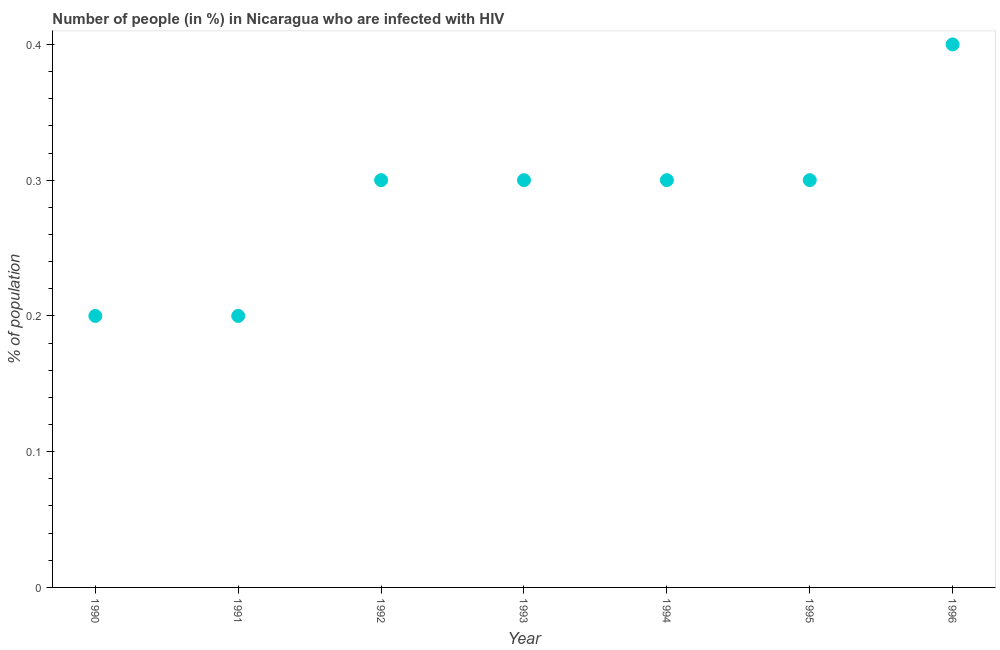What is the number of people infected with hiv in 1995?
Offer a very short reply. 0.3. What is the sum of the number of people infected with hiv?
Provide a succinct answer. 2. What is the difference between the number of people infected with hiv in 1991 and 1992?
Offer a terse response. -0.1. What is the average number of people infected with hiv per year?
Make the answer very short. 0.29. Do a majority of the years between 1993 and 1992 (inclusive) have number of people infected with hiv greater than 0.30000000000000004 %?
Your answer should be compact. No. What is the ratio of the number of people infected with hiv in 1992 to that in 1994?
Give a very brief answer. 1. What is the difference between the highest and the second highest number of people infected with hiv?
Make the answer very short. 0.1. Is the sum of the number of people infected with hiv in 1990 and 1995 greater than the maximum number of people infected with hiv across all years?
Provide a succinct answer. Yes. Does the number of people infected with hiv monotonically increase over the years?
Offer a terse response. No. Does the graph contain any zero values?
Offer a very short reply. No. What is the title of the graph?
Your answer should be compact. Number of people (in %) in Nicaragua who are infected with HIV. What is the label or title of the Y-axis?
Ensure brevity in your answer.  % of population. What is the % of population in 1990?
Offer a terse response. 0.2. What is the % of population in 1991?
Ensure brevity in your answer.  0.2. What is the % of population in 1992?
Your answer should be very brief. 0.3. What is the % of population in 1995?
Give a very brief answer. 0.3. What is the difference between the % of population in 1990 and 1992?
Offer a very short reply. -0.1. What is the difference between the % of population in 1990 and 1993?
Give a very brief answer. -0.1. What is the difference between the % of population in 1990 and 1995?
Keep it short and to the point. -0.1. What is the difference between the % of population in 1990 and 1996?
Give a very brief answer. -0.2. What is the difference between the % of population in 1991 and 1995?
Offer a terse response. -0.1. What is the difference between the % of population in 1992 and 1993?
Ensure brevity in your answer.  0. What is the difference between the % of population in 1992 and 1996?
Provide a short and direct response. -0.1. What is the difference between the % of population in 1993 and 1994?
Your answer should be very brief. 0. What is the difference between the % of population in 1993 and 1995?
Your answer should be very brief. 0. What is the difference between the % of population in 1994 and 1995?
Ensure brevity in your answer.  0. What is the difference between the % of population in 1994 and 1996?
Keep it short and to the point. -0.1. What is the difference between the % of population in 1995 and 1996?
Your answer should be very brief. -0.1. What is the ratio of the % of population in 1990 to that in 1992?
Provide a short and direct response. 0.67. What is the ratio of the % of population in 1990 to that in 1993?
Ensure brevity in your answer.  0.67. What is the ratio of the % of population in 1990 to that in 1994?
Provide a succinct answer. 0.67. What is the ratio of the % of population in 1990 to that in 1995?
Ensure brevity in your answer.  0.67. What is the ratio of the % of population in 1991 to that in 1992?
Your answer should be very brief. 0.67. What is the ratio of the % of population in 1991 to that in 1993?
Make the answer very short. 0.67. What is the ratio of the % of population in 1991 to that in 1994?
Ensure brevity in your answer.  0.67. What is the ratio of the % of population in 1991 to that in 1995?
Your response must be concise. 0.67. What is the ratio of the % of population in 1991 to that in 1996?
Offer a terse response. 0.5. What is the ratio of the % of population in 1992 to that in 1993?
Your answer should be compact. 1. What is the ratio of the % of population in 1993 to that in 1996?
Offer a very short reply. 0.75. What is the ratio of the % of population in 1995 to that in 1996?
Provide a succinct answer. 0.75. 